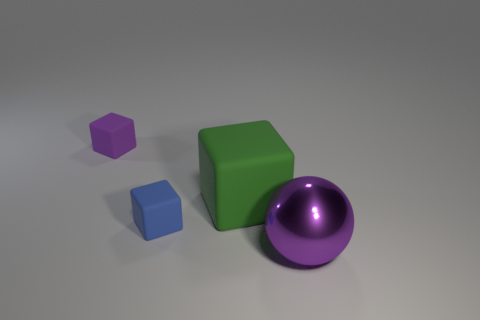Subtract all small blocks. How many blocks are left? 1 Add 2 green matte blocks. How many objects exist? 6 Subtract all green blocks. How many blocks are left? 2 Subtract all spheres. How many objects are left? 3 Subtract 1 blocks. How many blocks are left? 2 Subtract all red spheres. Subtract all brown cylinders. How many spheres are left? 1 Subtract all yellow cylinders. Subtract all small objects. How many objects are left? 2 Add 2 small purple matte objects. How many small purple matte objects are left? 3 Add 4 purple shiny things. How many purple shiny things exist? 5 Subtract 0 purple cylinders. How many objects are left? 4 